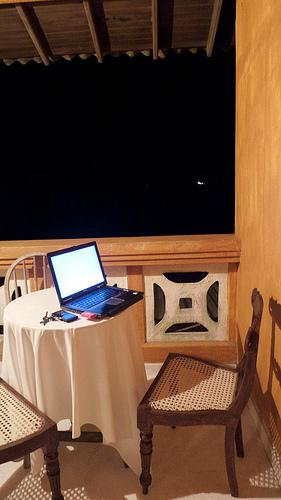Question: what is on the table?
Choices:
A. A phone.
B. A tablet.
C. A notepad.
D. A computer.
Answer with the letter. Answer: D Question: what color is the keyboard?
Choices:
A. Red.
B. Blue.
C. Silver.
D. White.
Answer with the letter. Answer: B Question: how many chairs are there?
Choices:
A. Two.
B. Three.
C. One.
D. Four.
Answer with the letter. Answer: B Question: when was this photo taken?
Choices:
A. Late afternoon.
B. Early morning.
C. Lunchtime.
D. At night.
Answer with the letter. Answer: D Question: what is by the computer?
Choices:
A. A phone.
B. A potted plant.
C. Some homework.
D. The iPod.
Answer with the letter. Answer: A Question: what is by the phone?
Choices:
A. Keys.
B. A charging cable.
C. Some loose change.
D. A leather wallet.
Answer with the letter. Answer: A 